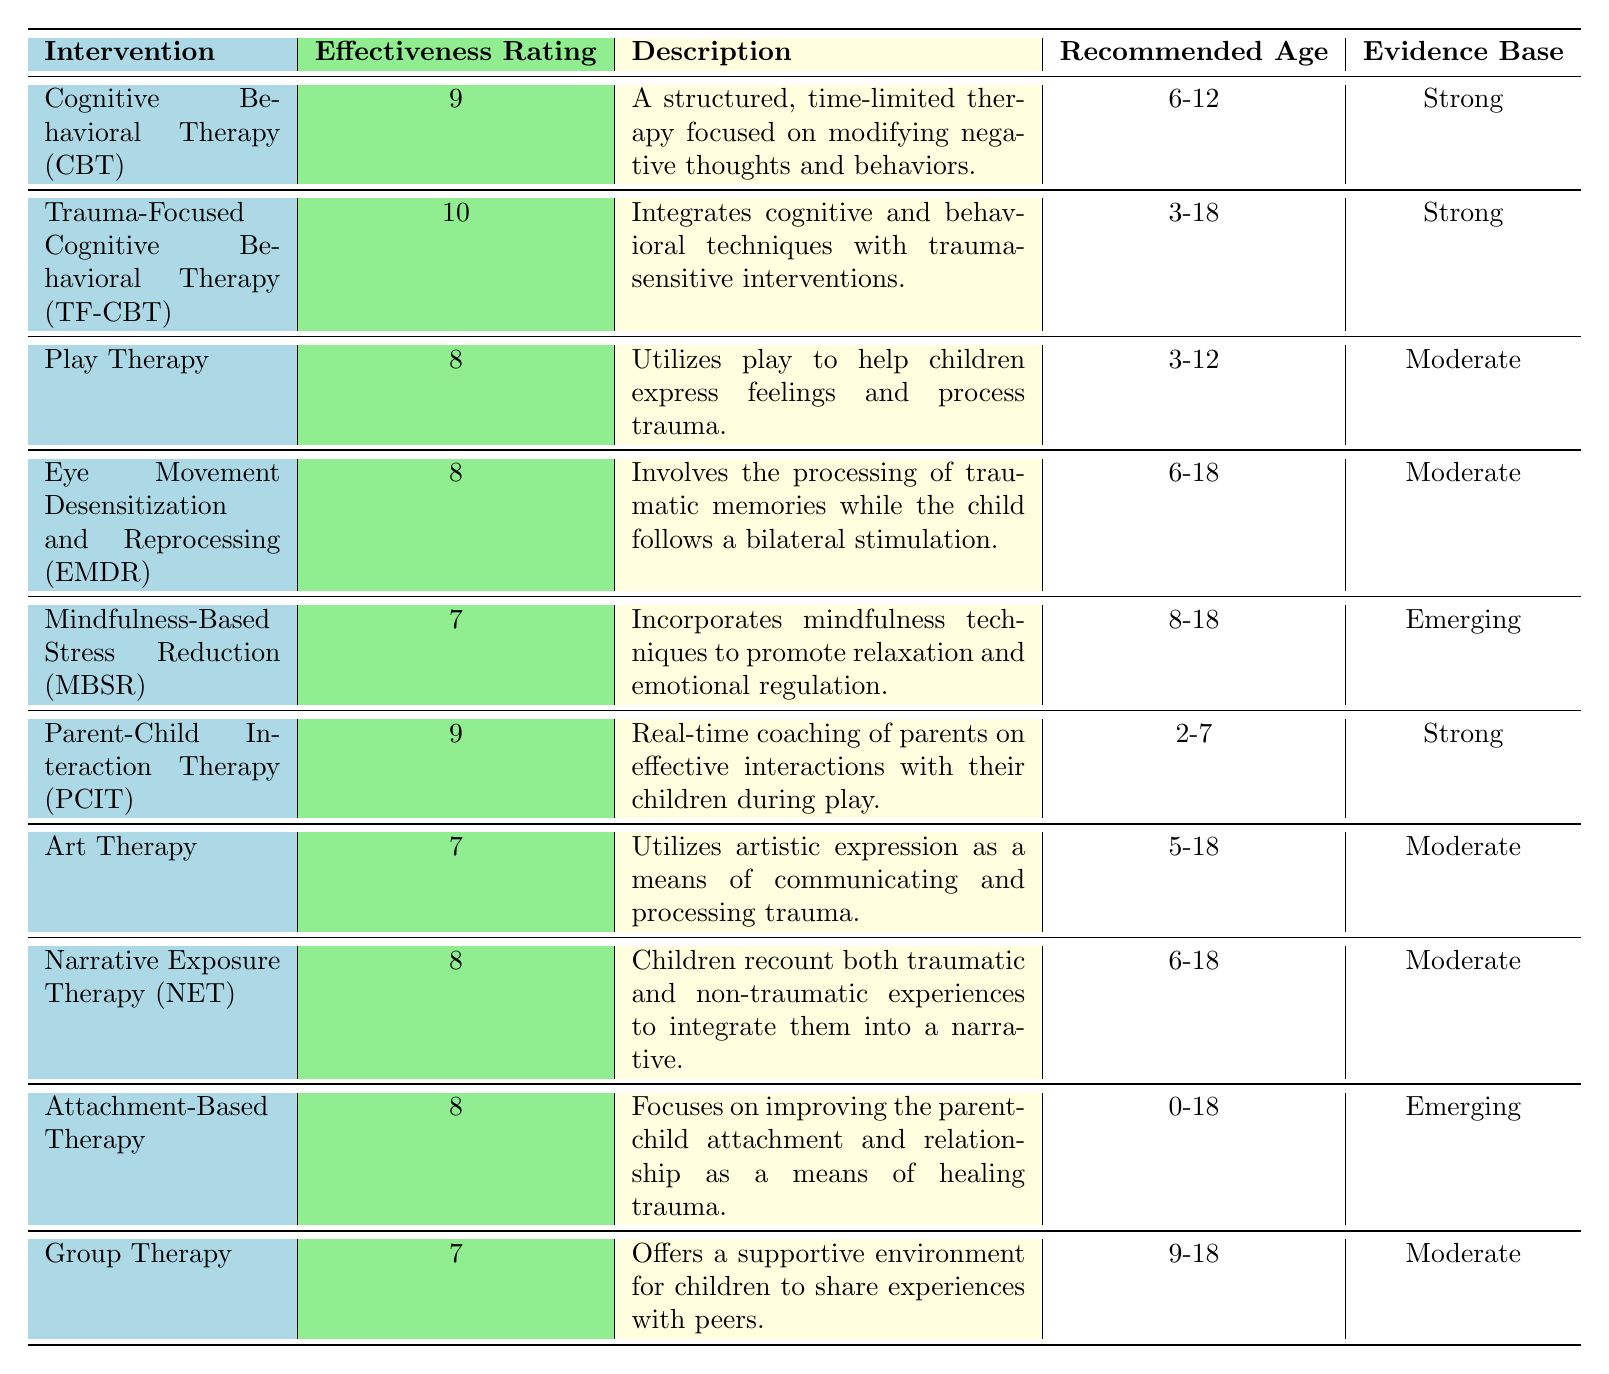What is the highest effectiveness rating among the therapeutic interventions listed? By inspecting the table, the highest effectiveness rating of 10 is found under the intervention "Trauma-Focused Cognitive Behavioral Therapy (TF-CBT)".
Answer: 10 How many interventions have an effectiveness rating of 8? The table lists three interventions with an effectiveness rating of 8: "Play Therapy", "Eye Movement Desensitization and Reprocessing (EMDR)", and "Narrative Exposure Therapy (NET)".
Answer: 3 Is "Cognitive Behavioral Therapy (CBT)" recommended for children younger than 6? The recommended age for "Cognitive Behavioral Therapy (CBT)" is 6-12, which means it is not suitable for children younger than 6.
Answer: No Which intervention has a description focusing on improving parent-child attachment? By examining the descriptions, "Attachment-Based Therapy" explicitly references improving parent-child attachment and relationships.
Answer: Attachment-Based Therapy What is the average effectiveness rating of the interventions with an evidence base rated as "Moderate"? The interventions with a "Moderate" evidence base are "Play Therapy", "Eye Movement Desensitization and Reprocessing (EMDR)", "Art Therapy", "Narrative Exposure Therapy", and "Group Therapy". Their ratings are 8, 8, 7, 8, and 7 respectively. The sum is 38 and the average is 38 divided by 5, which equals 7.6.
Answer: 7.6 Are there any interventions that target children aged 0-3? The table shows that the intervention "Attachment-Based Therapy" targets ages from 0-18, indicating it can support children from birth. However, no interventions explicitly target ages 0-3.
Answer: No Which intervention is recommended for the broadest age range? Reviewing the recommended ages, "Trauma-Focused Cognitive Behavioral Therapy (TF-CBT)" is suitable for ages 3-18, while "Attachment-Based Therapy" covers the range from 0-18, making it the intervention recommended for the broadest age range.
Answer: Attachment-Based Therapy What are the effectiveness ratings of interventions that include artistic expression as part of their methodology? The interventions that incorporate artistic expression are "Art Therapy" with a rating of 7 and "Play Therapy" with a rating of 8. So, the effectiveness ratings are 7 and 8.
Answer: 7 and 8 Which intervention provides real-time coaching to parents? The intervention that offers real-time coaching is "Parent-Child Interaction Therapy (PCIT)" as described in the table.
Answer: Parent-Child Interaction Therapy (PCIT) If a child is aged 5, which therapeutic interventions could they participate in? Looking at the recommended ages, "Play Therapy", "Art Therapy", and "Attachment-Based Therapy" are suitable for the age of 5. "Play Therapy" is recommended for ages 3-12, "Art Therapy" for ages 5-18, and "Attachment-Based Therapy" for ages 0-18.
Answer: Play Therapy, Art Therapy, Attachment-Based Therapy 